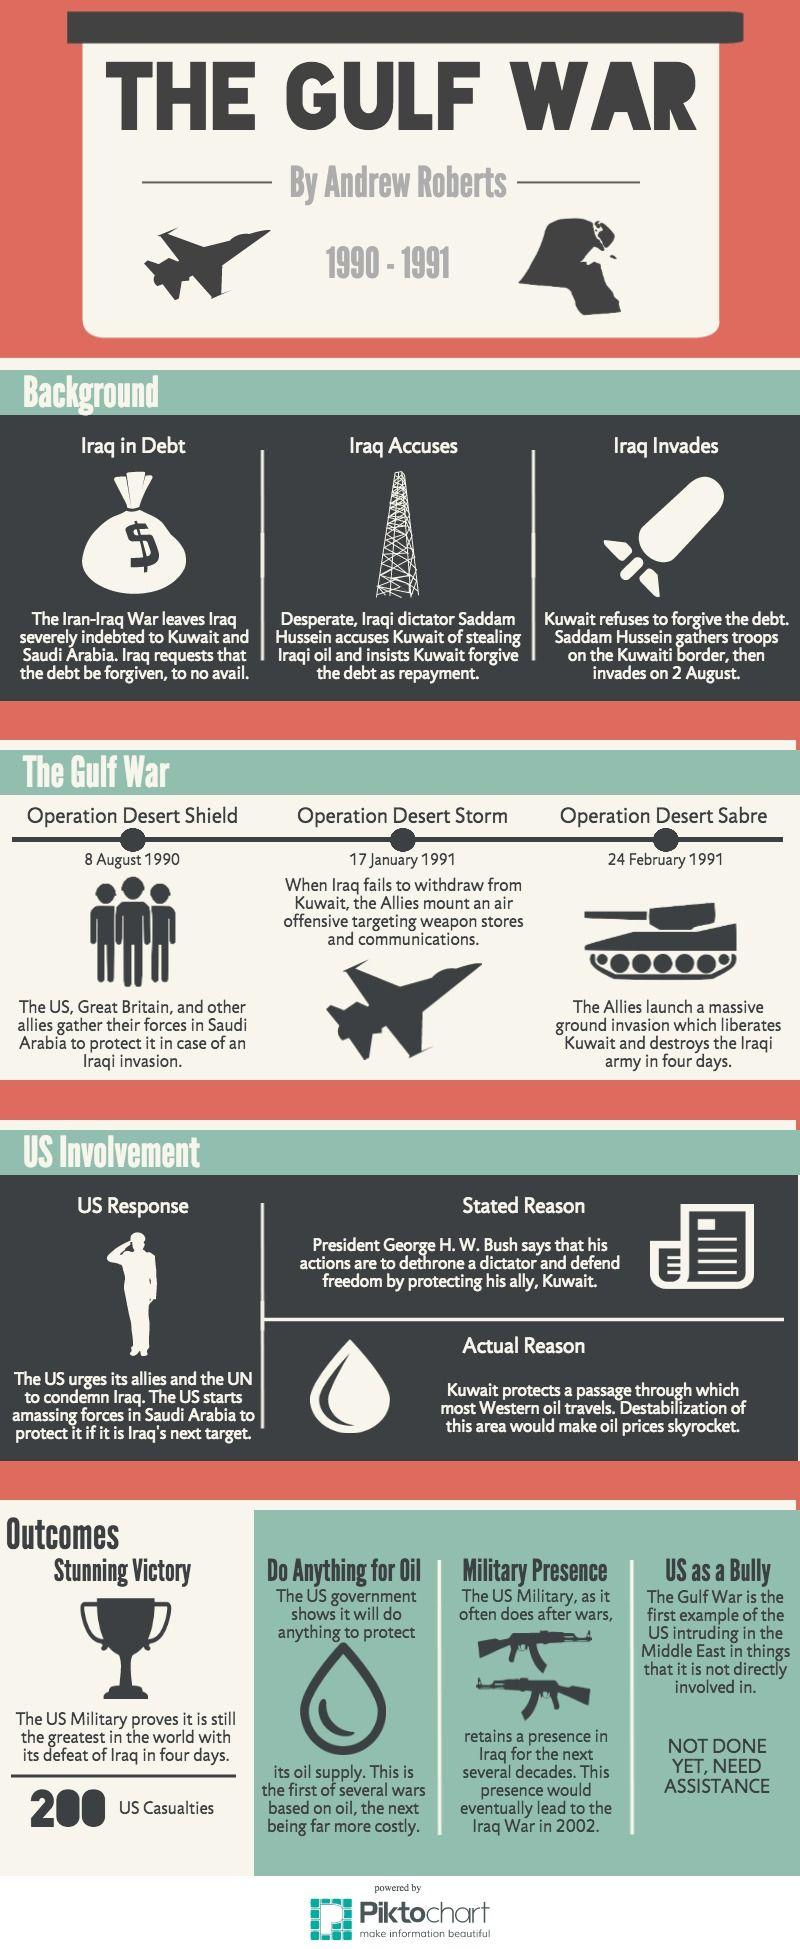Outline some significant characteristics in this image. After the Iran-Iraq war, Iraq was heavily indebted to Kuwait and Saudi Arabia. The US's involvement in the Gulf War was not motivated by a desire to protect Kuwait, but rather to prevent a sudden increase in oil prices that would harm the global economy. On August 2, 1990, Iraq invaded Kuwait. On August 8, 1990, Operation Desert Shield was launched. On January 17, 1991, the Allies launched an air invasion against Iraq's weapon stores and communications in order to disarm the country. 